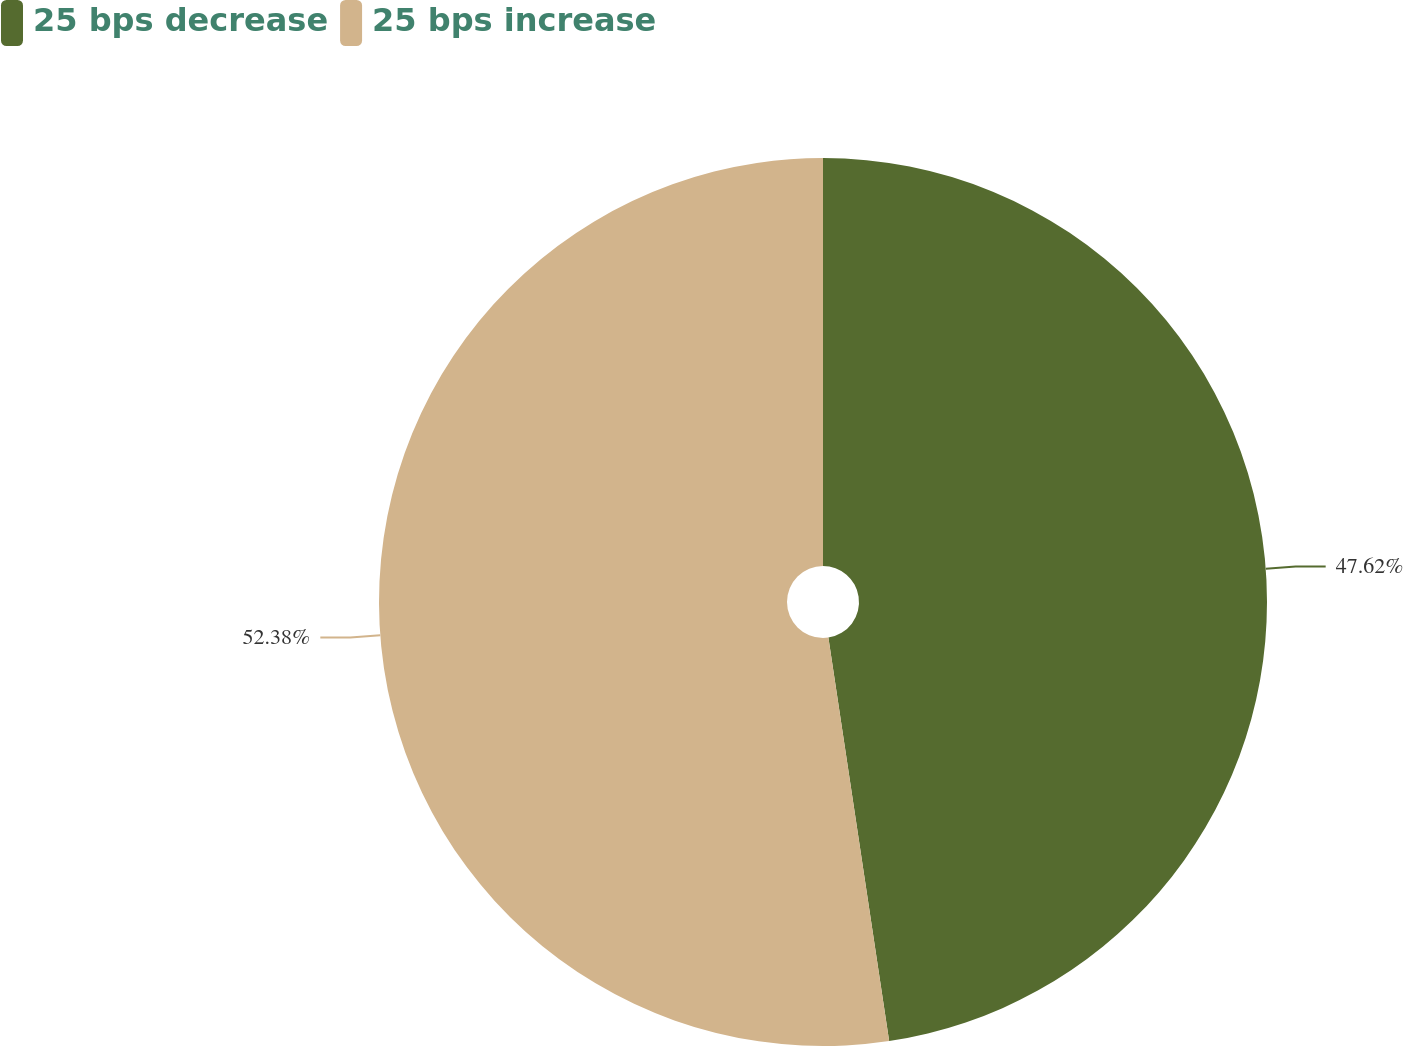<chart> <loc_0><loc_0><loc_500><loc_500><pie_chart><fcel>25 bps decrease<fcel>25 bps increase<nl><fcel>47.62%<fcel>52.38%<nl></chart> 